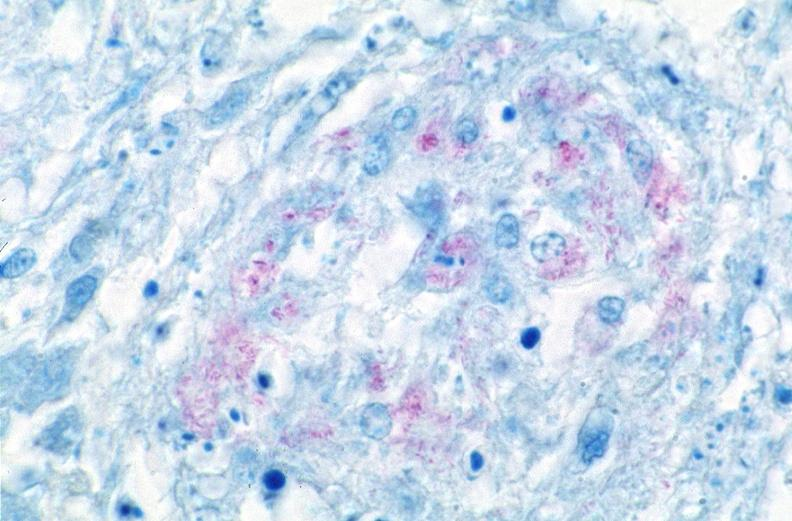where is this?
Answer the question using a single word or phrase. Lung 